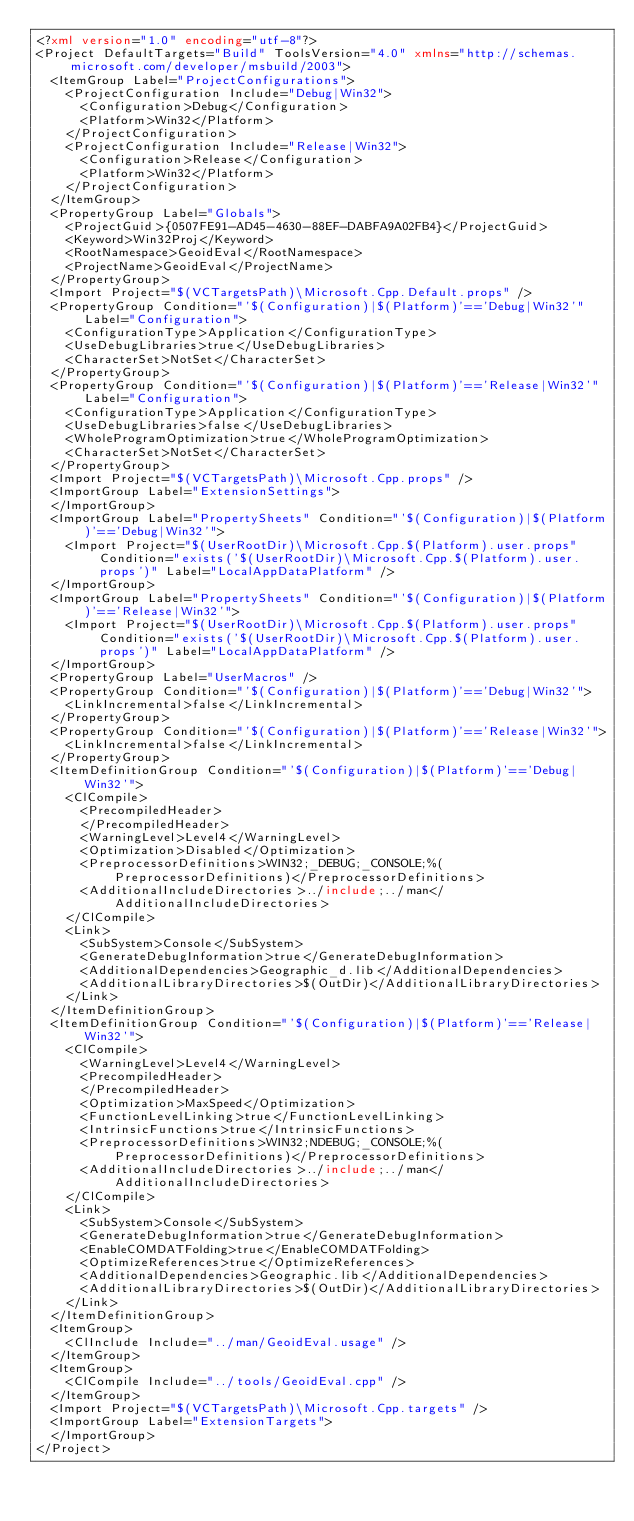Convert code to text. <code><loc_0><loc_0><loc_500><loc_500><_XML_><?xml version="1.0" encoding="utf-8"?>
<Project DefaultTargets="Build" ToolsVersion="4.0" xmlns="http://schemas.microsoft.com/developer/msbuild/2003">
  <ItemGroup Label="ProjectConfigurations">
    <ProjectConfiguration Include="Debug|Win32">
      <Configuration>Debug</Configuration>
      <Platform>Win32</Platform>
    </ProjectConfiguration>
    <ProjectConfiguration Include="Release|Win32">
      <Configuration>Release</Configuration>
      <Platform>Win32</Platform>
    </ProjectConfiguration>
  </ItemGroup>
  <PropertyGroup Label="Globals">
    <ProjectGuid>{0507FE91-AD45-4630-88EF-DABFA9A02FB4}</ProjectGuid>
    <Keyword>Win32Proj</Keyword>
    <RootNamespace>GeoidEval</RootNamespace>
    <ProjectName>GeoidEval</ProjectName>
  </PropertyGroup>
  <Import Project="$(VCTargetsPath)\Microsoft.Cpp.Default.props" />
  <PropertyGroup Condition="'$(Configuration)|$(Platform)'=='Debug|Win32'" Label="Configuration">
    <ConfigurationType>Application</ConfigurationType>
    <UseDebugLibraries>true</UseDebugLibraries>
    <CharacterSet>NotSet</CharacterSet>
  </PropertyGroup>
  <PropertyGroup Condition="'$(Configuration)|$(Platform)'=='Release|Win32'" Label="Configuration">
    <ConfigurationType>Application</ConfigurationType>
    <UseDebugLibraries>false</UseDebugLibraries>
    <WholeProgramOptimization>true</WholeProgramOptimization>
    <CharacterSet>NotSet</CharacterSet>
  </PropertyGroup>
  <Import Project="$(VCTargetsPath)\Microsoft.Cpp.props" />
  <ImportGroup Label="ExtensionSettings">
  </ImportGroup>
  <ImportGroup Label="PropertySheets" Condition="'$(Configuration)|$(Platform)'=='Debug|Win32'">
    <Import Project="$(UserRootDir)\Microsoft.Cpp.$(Platform).user.props" Condition="exists('$(UserRootDir)\Microsoft.Cpp.$(Platform).user.props')" Label="LocalAppDataPlatform" />
  </ImportGroup>
  <ImportGroup Label="PropertySheets" Condition="'$(Configuration)|$(Platform)'=='Release|Win32'">
    <Import Project="$(UserRootDir)\Microsoft.Cpp.$(Platform).user.props" Condition="exists('$(UserRootDir)\Microsoft.Cpp.$(Platform).user.props')" Label="LocalAppDataPlatform" />
  </ImportGroup>
  <PropertyGroup Label="UserMacros" />
  <PropertyGroup Condition="'$(Configuration)|$(Platform)'=='Debug|Win32'">
    <LinkIncremental>false</LinkIncremental>
  </PropertyGroup>
  <PropertyGroup Condition="'$(Configuration)|$(Platform)'=='Release|Win32'">
    <LinkIncremental>false</LinkIncremental>
  </PropertyGroup>
  <ItemDefinitionGroup Condition="'$(Configuration)|$(Platform)'=='Debug|Win32'">
    <ClCompile>
      <PrecompiledHeader>
      </PrecompiledHeader>
      <WarningLevel>Level4</WarningLevel>
      <Optimization>Disabled</Optimization>
      <PreprocessorDefinitions>WIN32;_DEBUG;_CONSOLE;%(PreprocessorDefinitions)</PreprocessorDefinitions>
      <AdditionalIncludeDirectories>../include;../man</AdditionalIncludeDirectories>
    </ClCompile>
    <Link>
      <SubSystem>Console</SubSystem>
      <GenerateDebugInformation>true</GenerateDebugInformation>
      <AdditionalDependencies>Geographic_d.lib</AdditionalDependencies>
      <AdditionalLibraryDirectories>$(OutDir)</AdditionalLibraryDirectories>
    </Link>
  </ItemDefinitionGroup>
  <ItemDefinitionGroup Condition="'$(Configuration)|$(Platform)'=='Release|Win32'">
    <ClCompile>
      <WarningLevel>Level4</WarningLevel>
      <PrecompiledHeader>
      </PrecompiledHeader>
      <Optimization>MaxSpeed</Optimization>
      <FunctionLevelLinking>true</FunctionLevelLinking>
      <IntrinsicFunctions>true</IntrinsicFunctions>
      <PreprocessorDefinitions>WIN32;NDEBUG;_CONSOLE;%(PreprocessorDefinitions)</PreprocessorDefinitions>
      <AdditionalIncludeDirectories>../include;../man</AdditionalIncludeDirectories>
    </ClCompile>
    <Link>
      <SubSystem>Console</SubSystem>
      <GenerateDebugInformation>true</GenerateDebugInformation>
      <EnableCOMDATFolding>true</EnableCOMDATFolding>
      <OptimizeReferences>true</OptimizeReferences>
      <AdditionalDependencies>Geographic.lib</AdditionalDependencies>
      <AdditionalLibraryDirectories>$(OutDir)</AdditionalLibraryDirectories>
    </Link>
  </ItemDefinitionGroup>
  <ItemGroup>
    <ClInclude Include="../man/GeoidEval.usage" />
  </ItemGroup>
  <ItemGroup>
    <ClCompile Include="../tools/GeoidEval.cpp" />
  </ItemGroup>
  <Import Project="$(VCTargetsPath)\Microsoft.Cpp.targets" />
  <ImportGroup Label="ExtensionTargets">
  </ImportGroup>
</Project>
</code> 